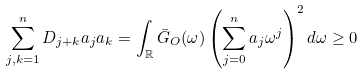Convert formula to latex. <formula><loc_0><loc_0><loc_500><loc_500>\sum _ { j , k = 1 } ^ { n } D _ { j + k } a _ { j } a _ { k } = \int _ { \mathbb { R } } \bar { G } _ { O } ( \omega ) \left ( \sum _ { j = 0 } ^ { n } a _ { j } \omega ^ { j } \right ) ^ { 2 } d \omega \geq 0</formula> 